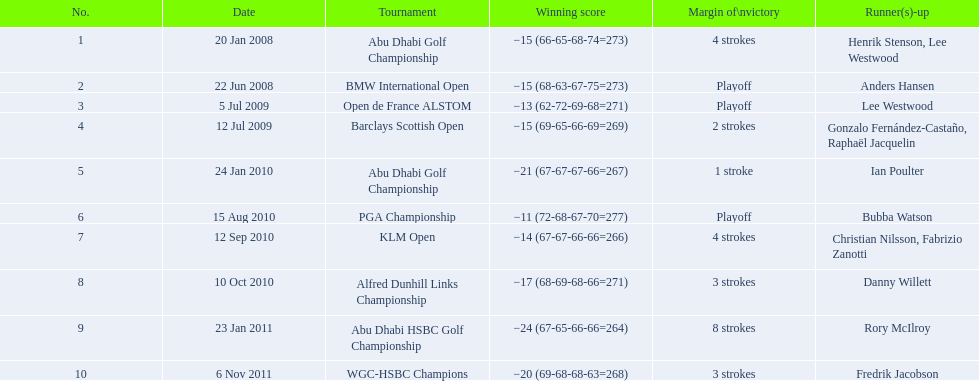In how many instances has he emerged victorious in tournaments by a lead of 3 strokes or greater? 5. 